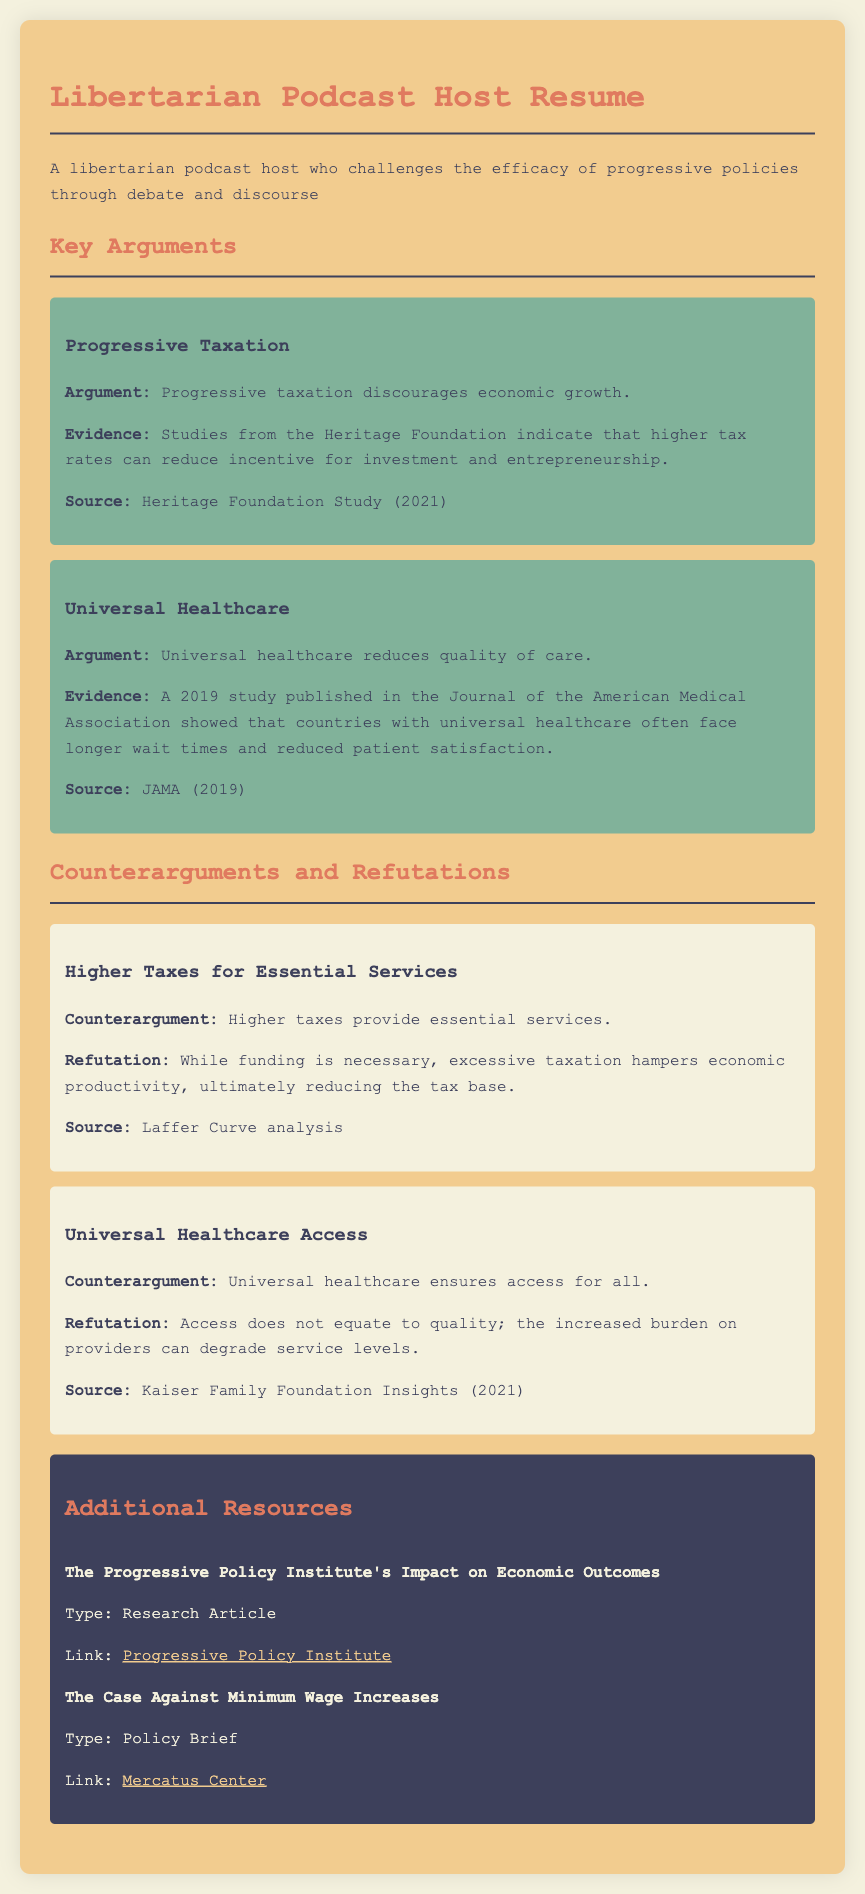What is the main argument against progressive taxation? The main argument states that progressive taxation discourages economic growth, which is presented as a key argument in the document.
Answer: Discourages economic growth What source supports the argument about universal healthcare? The document cites a 2019 study published in the Journal of the American Medical Association as evidence for the argument against universal healthcare.
Answer: JAMA (2019) What does the counterargument regarding higher taxes claim? The counterargument claims that higher taxes provide essential services, which is a stated point in the document.
Answer: Provide essential services What is the refutation to the claim about universal healthcare access? The refutation states that access does not equate to quality, emphasizing a critical aspect of the argument presented.
Answer: Access does not equate to quality What type of resources are listed in the document? The document includes research articles and policy briefs as types of resources provided for further reading.
Answer: Research Article, Policy Brief 